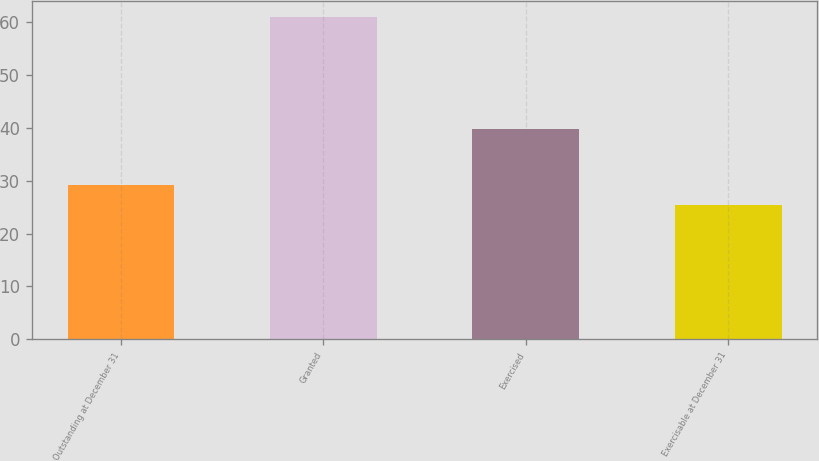Convert chart. <chart><loc_0><loc_0><loc_500><loc_500><bar_chart><fcel>Outstanding at December 31<fcel>Granted<fcel>Exercised<fcel>Exercisable at December 31<nl><fcel>29.27<fcel>60.89<fcel>39.72<fcel>25.32<nl></chart> 